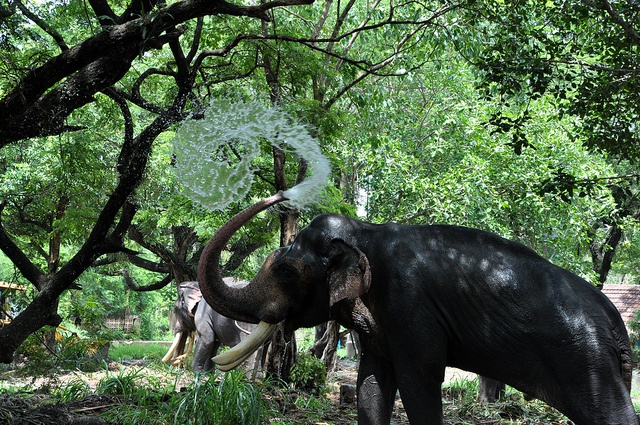Describe the objects in this image and their specific colors. I can see elephant in teal, black, gray, and darkgray tones and elephant in teal, black, darkgray, gray, and lightgray tones in this image. 